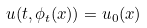<formula> <loc_0><loc_0><loc_500><loc_500>u ( t , \phi _ { t } ( x ) ) = u _ { 0 } ( x ) \text { }</formula> 